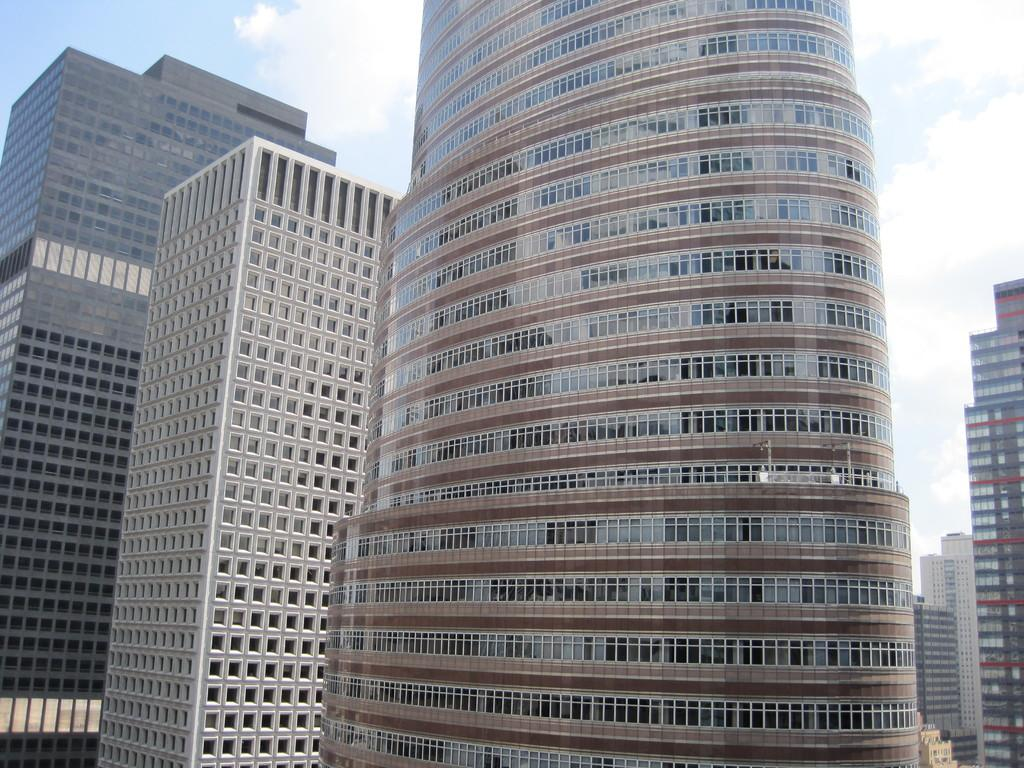What type of buildings can be seen in the image? There are big buildings with glass walls in the image. What color is the sky in the image? The sky is blue in the image. What type of pies are being served at the night event in the image? There is no event or pies present in the image; it only features big buildings with glass walls and a blue sky. 